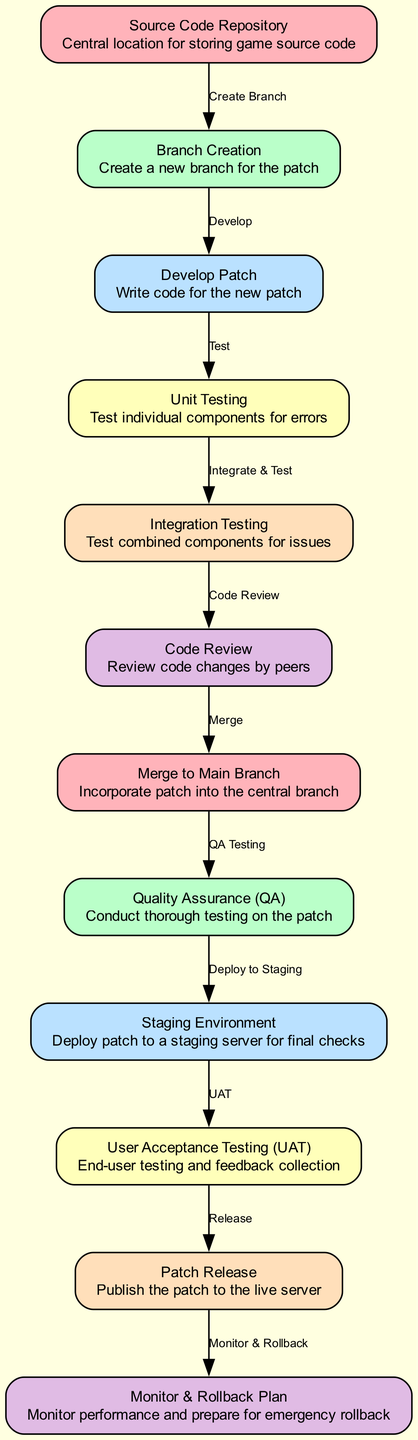What is the first step in the patch deployment process? The diagram shows that the first step is the "Source Code Repository," which is where the game source code is stored. This step is indicated at the top of the flow, clearly identified as the starting point.
Answer: Source Code Repository How many testing phases are included in the diagram? By examining the diagram, we can see three distinct testing phases labeled as "Unit Testing," "Integration Testing," and "Quality Assurance (QA)." Counting these gives us the total number of testing phases.
Answer: Three What follows after "Merge to Main Branch"? The flow indicates that after the "Merge to Main Branch," the next step is "Quality Assurance (QA)." This is represented with an edge connecting these two nodes, clearly showing the sequence.
Answer: Quality Assurance (QA) Which step involves end-user testing? The diagram specifies that "User Acceptance Testing (UAT)" is the step that involves end-user testing. It is placed towards the end of the process, following the "Staging Environment."
Answer: User Acceptance Testing (UAT) What are the last two steps before the patch is released? According to the flow sequence in the diagram, the two steps immediately preceding the "Patch Release" are "User Acceptance Testing (UAT)" and "Patch Release" itself. The last step involves monitoring and preparing for a rollback after the release.
Answer: User Acceptance Testing (UAT) and Monitor & Rollback Plan What is the role of "Code Review" in the patch deployment process? The "Code Review" step involves reviewing code changes by peers, which is crucial for ensuring code quality. It occurs after "Integration Testing," which indicates that the code has passed its initial tests and is ready for peer evaluation.
Answer: Review code changes by peers How does the patch move from testing to release? The patch transitions from "User Acceptance Testing (UAT)" directly to the "Patch Release" step, which is indicated by the edge connecting these two nodes. This shows that once user testing is complete, the patch is ready to be published.
Answer: Through User Acceptance Testing (UAT) Which node indicates a plan for handling issues post-release? The node labeled "Monitor & Rollback Plan" is specifically designed to deal with issues that might arise after the patch is released. It is the final step in the diagram, indicating that monitoring performance and preparing for an emergency rollback are necessary actions post-deployment.
Answer: Monitor & Rollback Plan 